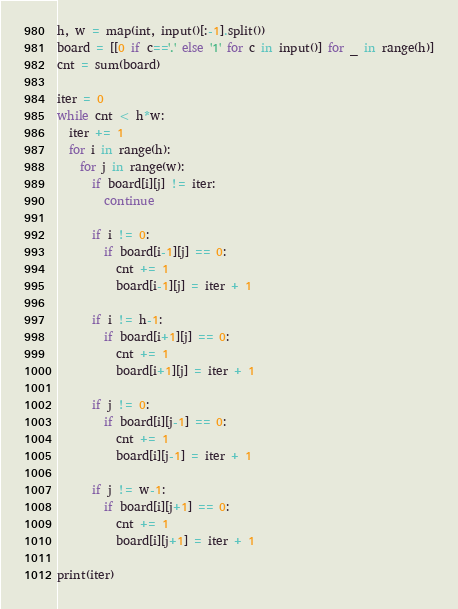<code> <loc_0><loc_0><loc_500><loc_500><_Python_>h, w = map(int, input()[:-1].split())
board = [[0 if c=='.' else '1' for c in input()] for _ in range(h)]
cnt = sum(board)

iter = 0
while cnt < h*w:
  iter += 1
  for i in range(h):
    for j in range(w):
      if board[i][j] != iter:
        continue
      
      if i != 0:
        if board[i-1][j] == 0:
          cnt += 1
          board[i-1][j] = iter + 1
      
      if i != h-1:
        if board[i+1][j] == 0:
          cnt += 1
          board[i+1][j] = iter + 1
      
      if j != 0:
        if board[i][j-1] == 0:
          cnt += 1
          board[i][j-1] = iter + 1
      
      if j != w-1:
        if board[i][j+1] == 0:
          cnt += 1
          board[i][j+1] = iter + 1
            
print(iter)
</code> 